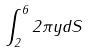Convert formula to latex. <formula><loc_0><loc_0><loc_500><loc_500>\int _ { 2 } ^ { 6 } 2 \pi y d S</formula> 